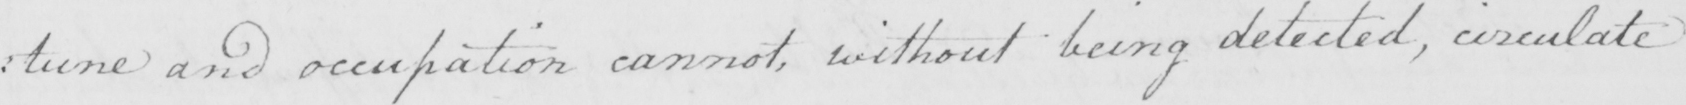Can you tell me what this handwritten text says? : tune and occupation cannot , without being detected , circulate 